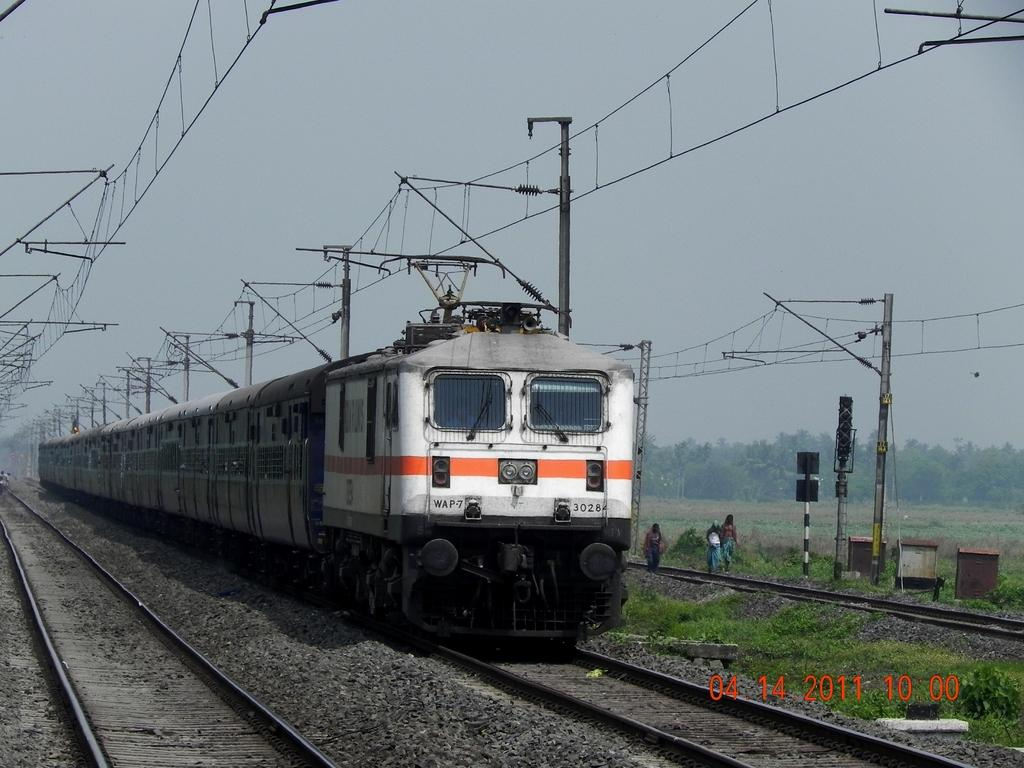What is the main subject of the image? There is a train on a railway track in the image. What else can be seen in the image besides the train? Poles, grass, trees, and three persons walking on the ground are visible in the image. What is the condition of the sky in the image? The sky is visible in the background of the image. Where is the quiver of arrows located in the image? There is no quiver of arrows present in the image. Can you describe the cactus in the image? There is no cactus present in the image. 